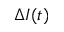Convert formula to latex. <formula><loc_0><loc_0><loc_500><loc_500>\Delta I ( t )</formula> 